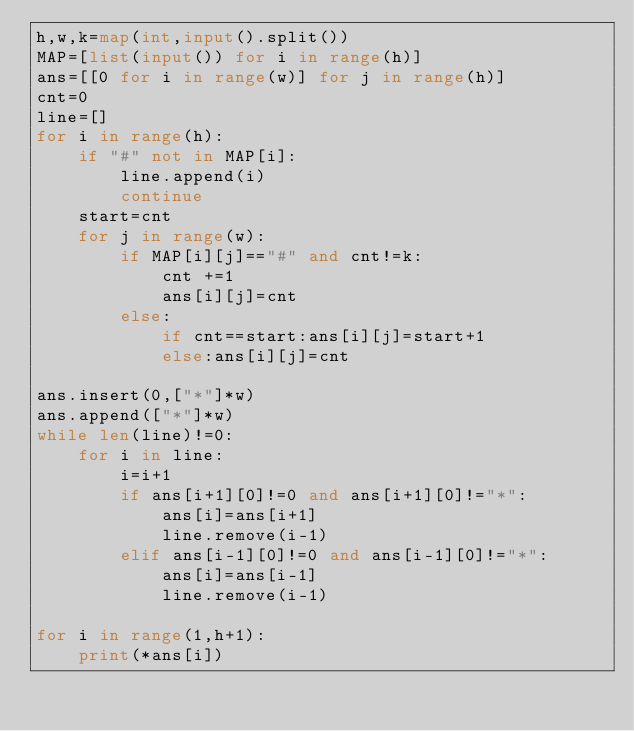<code> <loc_0><loc_0><loc_500><loc_500><_Python_>h,w,k=map(int,input().split())
MAP=[list(input()) for i in range(h)]
ans=[[0 for i in range(w)] for j in range(h)]
cnt=0
line=[]
for i in range(h):
    if "#" not in MAP[i]:
        line.append(i)
        continue
    start=cnt
    for j in range(w):
        if MAP[i][j]=="#" and cnt!=k:
            cnt +=1
            ans[i][j]=cnt
        else:
            if cnt==start:ans[i][j]=start+1
            else:ans[i][j]=cnt

ans.insert(0,["*"]*w)
ans.append(["*"]*w)
while len(line)!=0:
    for i in line:
        i=i+1
        if ans[i+1][0]!=0 and ans[i+1][0]!="*":
            ans[i]=ans[i+1]
            line.remove(i-1)
        elif ans[i-1][0]!=0 and ans[i-1][0]!="*":
            ans[i]=ans[i-1]
            line.remove(i-1)

for i in range(1,h+1):
    print(*ans[i])</code> 